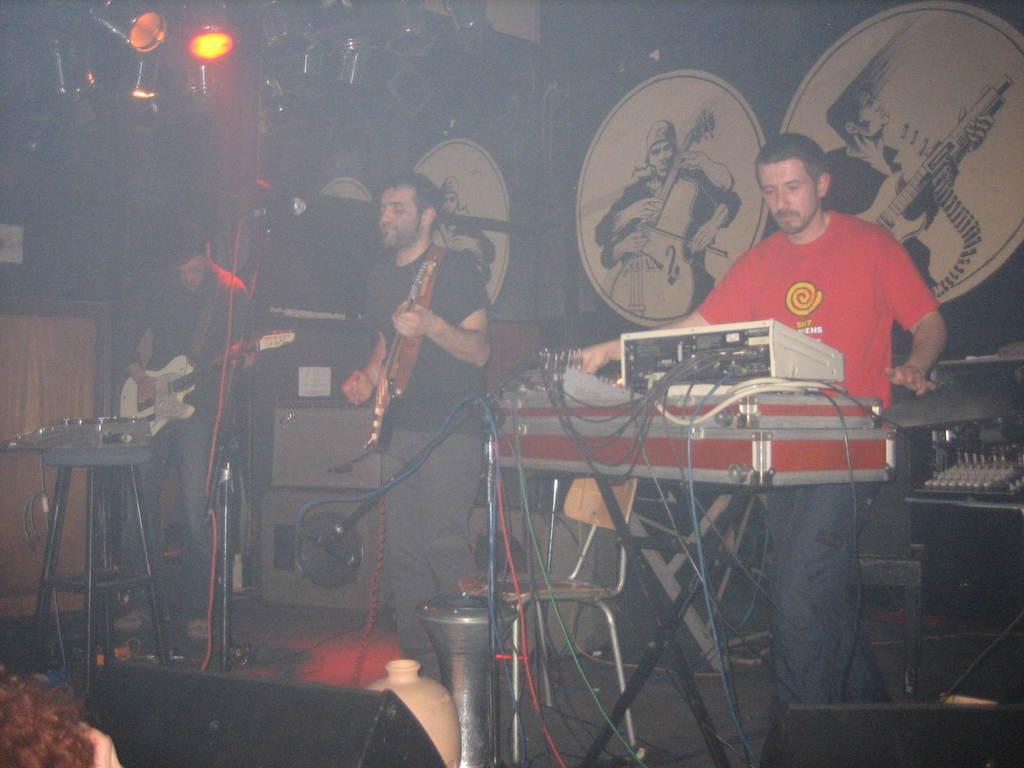Describe this image in one or two sentences. In this picture there are two persons standing and playing guitar and there is a person standing and there are devices on the table and on the stool and there are wires. At the back there are devices and there are pictures of group of people on the wall. At the top there are lights. At the bottom there are speakers. At the bottom left there is a person. 